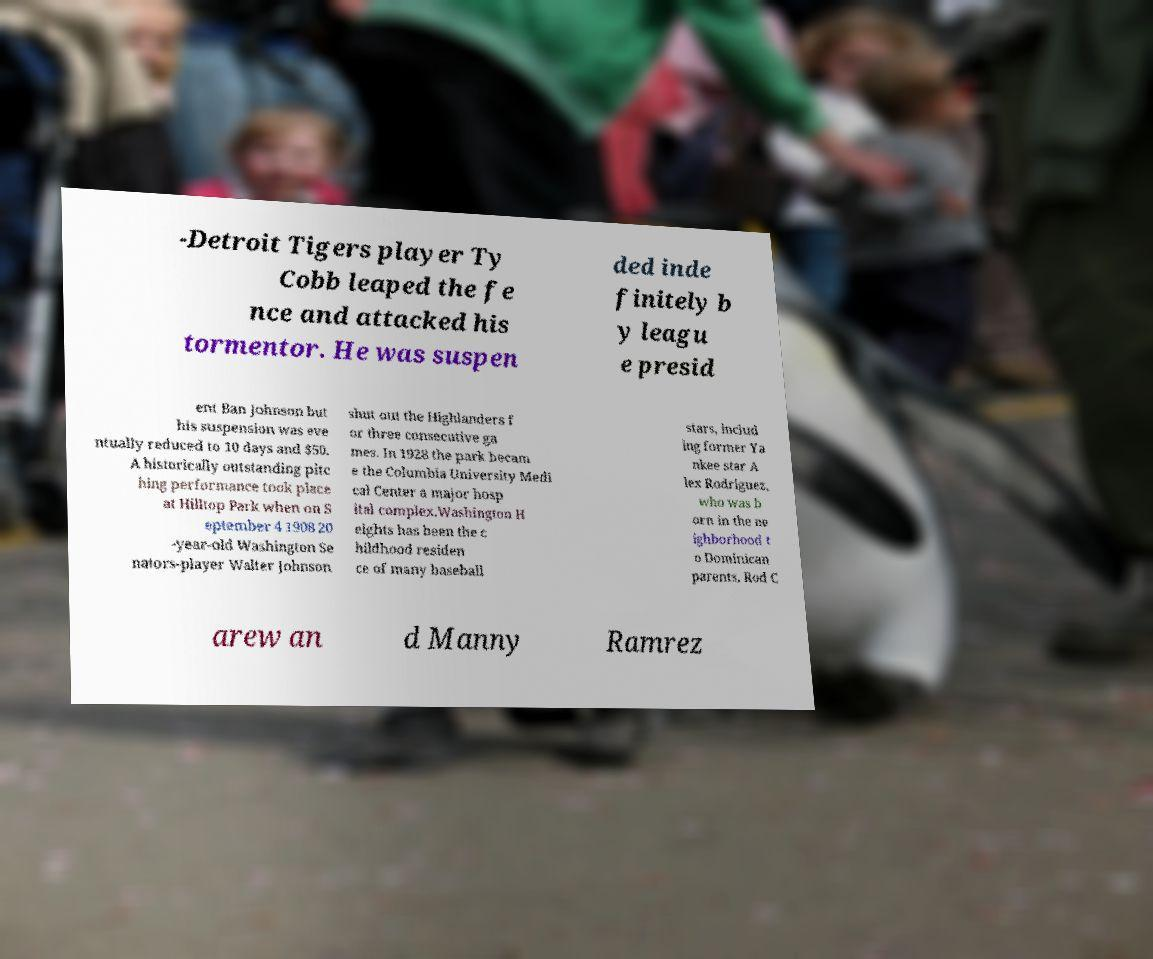For documentation purposes, I need the text within this image transcribed. Could you provide that? -Detroit Tigers player Ty Cobb leaped the fe nce and attacked his tormentor. He was suspen ded inde finitely b y leagu e presid ent Ban Johnson but his suspension was eve ntually reduced to 10 days and $50. A historically outstanding pitc hing performance took place at Hilltop Park when on S eptember 4 1908 20 -year-old Washington Se nators-player Walter Johnson shut out the Highlanders f or three consecutive ga mes. In 1928 the park becam e the Columbia University Medi cal Center a major hosp ital complex.Washington H eights has been the c hildhood residen ce of many baseball stars, includ ing former Ya nkee star A lex Rodriguez, who was b orn in the ne ighborhood t o Dominican parents. Rod C arew an d Manny Ramrez 